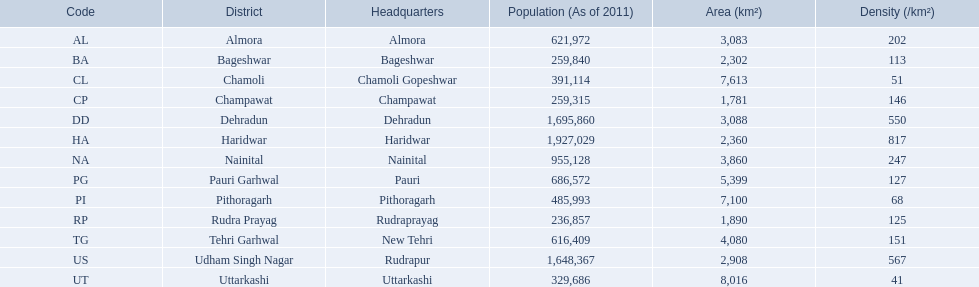What are the denominations of all the districts? Almora, Bageshwar, Chamoli, Champawat, Dehradun, Haridwar, Nainital, Pauri Garhwal, Pithoragarh, Rudra Prayag, Tehri Garhwal, Udham Singh Nagar, Uttarkashi. What scale of densities do these districts embrace? 202, 113, 51, 146, 550, 817, 247, 127, 68, 125, 151, 567, 41. Could you help me parse every detail presented in this table? {'header': ['Code', 'District', 'Headquarters', 'Population (As of 2011)', 'Area (km²)', 'Density (/km²)'], 'rows': [['AL', 'Almora', 'Almora', '621,972', '3,083', '202'], ['BA', 'Bageshwar', 'Bageshwar', '259,840', '2,302', '113'], ['CL', 'Chamoli', 'Chamoli Gopeshwar', '391,114', '7,613', '51'], ['CP', 'Champawat', 'Champawat', '259,315', '1,781', '146'], ['DD', 'Dehradun', 'Dehradun', '1,695,860', '3,088', '550'], ['HA', 'Haridwar', 'Haridwar', '1,927,029', '2,360', '817'], ['NA', 'Nainital', 'Nainital', '955,128', '3,860', '247'], ['PG', 'Pauri Garhwal', 'Pauri', '686,572', '5,399', '127'], ['PI', 'Pithoragarh', 'Pithoragarh', '485,993', '7,100', '68'], ['RP', 'Rudra Prayag', 'Rudraprayag', '236,857', '1,890', '125'], ['TG', 'Tehri Garhwal', 'New Tehri', '616,409', '4,080', '151'], ['US', 'Udham Singh Nagar', 'Rudrapur', '1,648,367', '2,908', '567'], ['UT', 'Uttarkashi', 'Uttarkashi', '329,686', '8,016', '41']]} Which district holds a density of 51? Chamoli. What are the appellations of all the districts? Almora, Bageshwar, Chamoli, Champawat, Dehradun, Haridwar, Nainital, Pauri Garhwal, Pithoragarh, Rudra Prayag, Tehri Garhwal, Udham Singh Nagar, Uttarkashi. What scope of densities do these districts include? 202, 113, 51, 146, 550, 817, 247, 127, 68, 125, 151, 567, 41. Which district possesses a density of 51? Chamoli. 